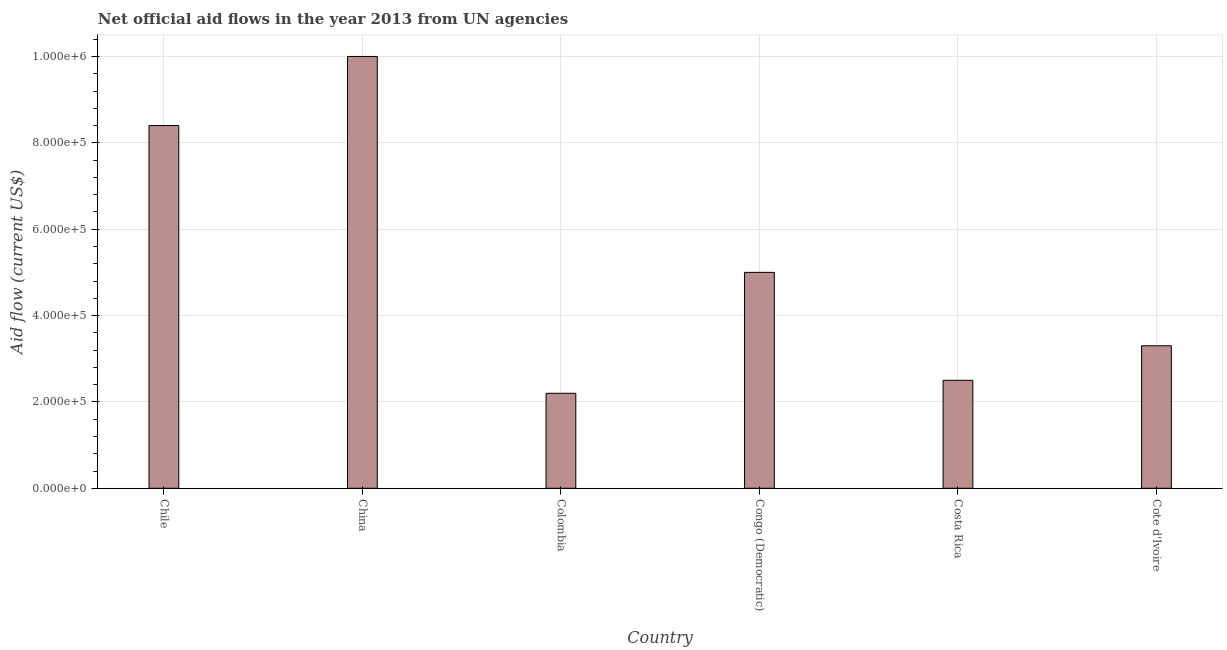Does the graph contain any zero values?
Your response must be concise. No. What is the title of the graph?
Offer a very short reply. Net official aid flows in the year 2013 from UN agencies. What is the label or title of the Y-axis?
Your response must be concise. Aid flow (current US$). What is the net official flows from un agencies in Chile?
Offer a terse response. 8.40e+05. Across all countries, what is the minimum net official flows from un agencies?
Your answer should be compact. 2.20e+05. In which country was the net official flows from un agencies maximum?
Provide a short and direct response. China. What is the sum of the net official flows from un agencies?
Your answer should be compact. 3.14e+06. What is the difference between the net official flows from un agencies in Chile and Colombia?
Keep it short and to the point. 6.20e+05. What is the average net official flows from un agencies per country?
Make the answer very short. 5.23e+05. What is the median net official flows from un agencies?
Provide a short and direct response. 4.15e+05. What is the ratio of the net official flows from un agencies in China to that in Colombia?
Your answer should be very brief. 4.54. Is the difference between the net official flows from un agencies in Chile and Colombia greater than the difference between any two countries?
Your answer should be very brief. No. What is the difference between the highest and the lowest net official flows from un agencies?
Keep it short and to the point. 7.80e+05. In how many countries, is the net official flows from un agencies greater than the average net official flows from un agencies taken over all countries?
Your answer should be very brief. 2. How many bars are there?
Your answer should be very brief. 6. How many countries are there in the graph?
Your answer should be very brief. 6. Are the values on the major ticks of Y-axis written in scientific E-notation?
Provide a short and direct response. Yes. What is the Aid flow (current US$) in Chile?
Provide a short and direct response. 8.40e+05. What is the Aid flow (current US$) in Congo (Democratic)?
Offer a terse response. 5.00e+05. What is the Aid flow (current US$) in Costa Rica?
Ensure brevity in your answer.  2.50e+05. What is the difference between the Aid flow (current US$) in Chile and China?
Your answer should be very brief. -1.60e+05. What is the difference between the Aid flow (current US$) in Chile and Colombia?
Make the answer very short. 6.20e+05. What is the difference between the Aid flow (current US$) in Chile and Costa Rica?
Ensure brevity in your answer.  5.90e+05. What is the difference between the Aid flow (current US$) in Chile and Cote d'Ivoire?
Give a very brief answer. 5.10e+05. What is the difference between the Aid flow (current US$) in China and Colombia?
Your answer should be very brief. 7.80e+05. What is the difference between the Aid flow (current US$) in China and Congo (Democratic)?
Ensure brevity in your answer.  5.00e+05. What is the difference between the Aid flow (current US$) in China and Costa Rica?
Give a very brief answer. 7.50e+05. What is the difference between the Aid flow (current US$) in China and Cote d'Ivoire?
Provide a succinct answer. 6.70e+05. What is the difference between the Aid flow (current US$) in Colombia and Congo (Democratic)?
Keep it short and to the point. -2.80e+05. What is the difference between the Aid flow (current US$) in Colombia and Cote d'Ivoire?
Offer a very short reply. -1.10e+05. What is the difference between the Aid flow (current US$) in Congo (Democratic) and Costa Rica?
Give a very brief answer. 2.50e+05. What is the ratio of the Aid flow (current US$) in Chile to that in China?
Make the answer very short. 0.84. What is the ratio of the Aid flow (current US$) in Chile to that in Colombia?
Your response must be concise. 3.82. What is the ratio of the Aid flow (current US$) in Chile to that in Congo (Democratic)?
Your response must be concise. 1.68. What is the ratio of the Aid flow (current US$) in Chile to that in Costa Rica?
Ensure brevity in your answer.  3.36. What is the ratio of the Aid flow (current US$) in Chile to that in Cote d'Ivoire?
Keep it short and to the point. 2.54. What is the ratio of the Aid flow (current US$) in China to that in Colombia?
Keep it short and to the point. 4.54. What is the ratio of the Aid flow (current US$) in China to that in Cote d'Ivoire?
Provide a short and direct response. 3.03. What is the ratio of the Aid flow (current US$) in Colombia to that in Congo (Democratic)?
Offer a very short reply. 0.44. What is the ratio of the Aid flow (current US$) in Colombia to that in Costa Rica?
Provide a succinct answer. 0.88. What is the ratio of the Aid flow (current US$) in Colombia to that in Cote d'Ivoire?
Your answer should be very brief. 0.67. What is the ratio of the Aid flow (current US$) in Congo (Democratic) to that in Costa Rica?
Provide a succinct answer. 2. What is the ratio of the Aid flow (current US$) in Congo (Democratic) to that in Cote d'Ivoire?
Provide a short and direct response. 1.51. What is the ratio of the Aid flow (current US$) in Costa Rica to that in Cote d'Ivoire?
Provide a succinct answer. 0.76. 